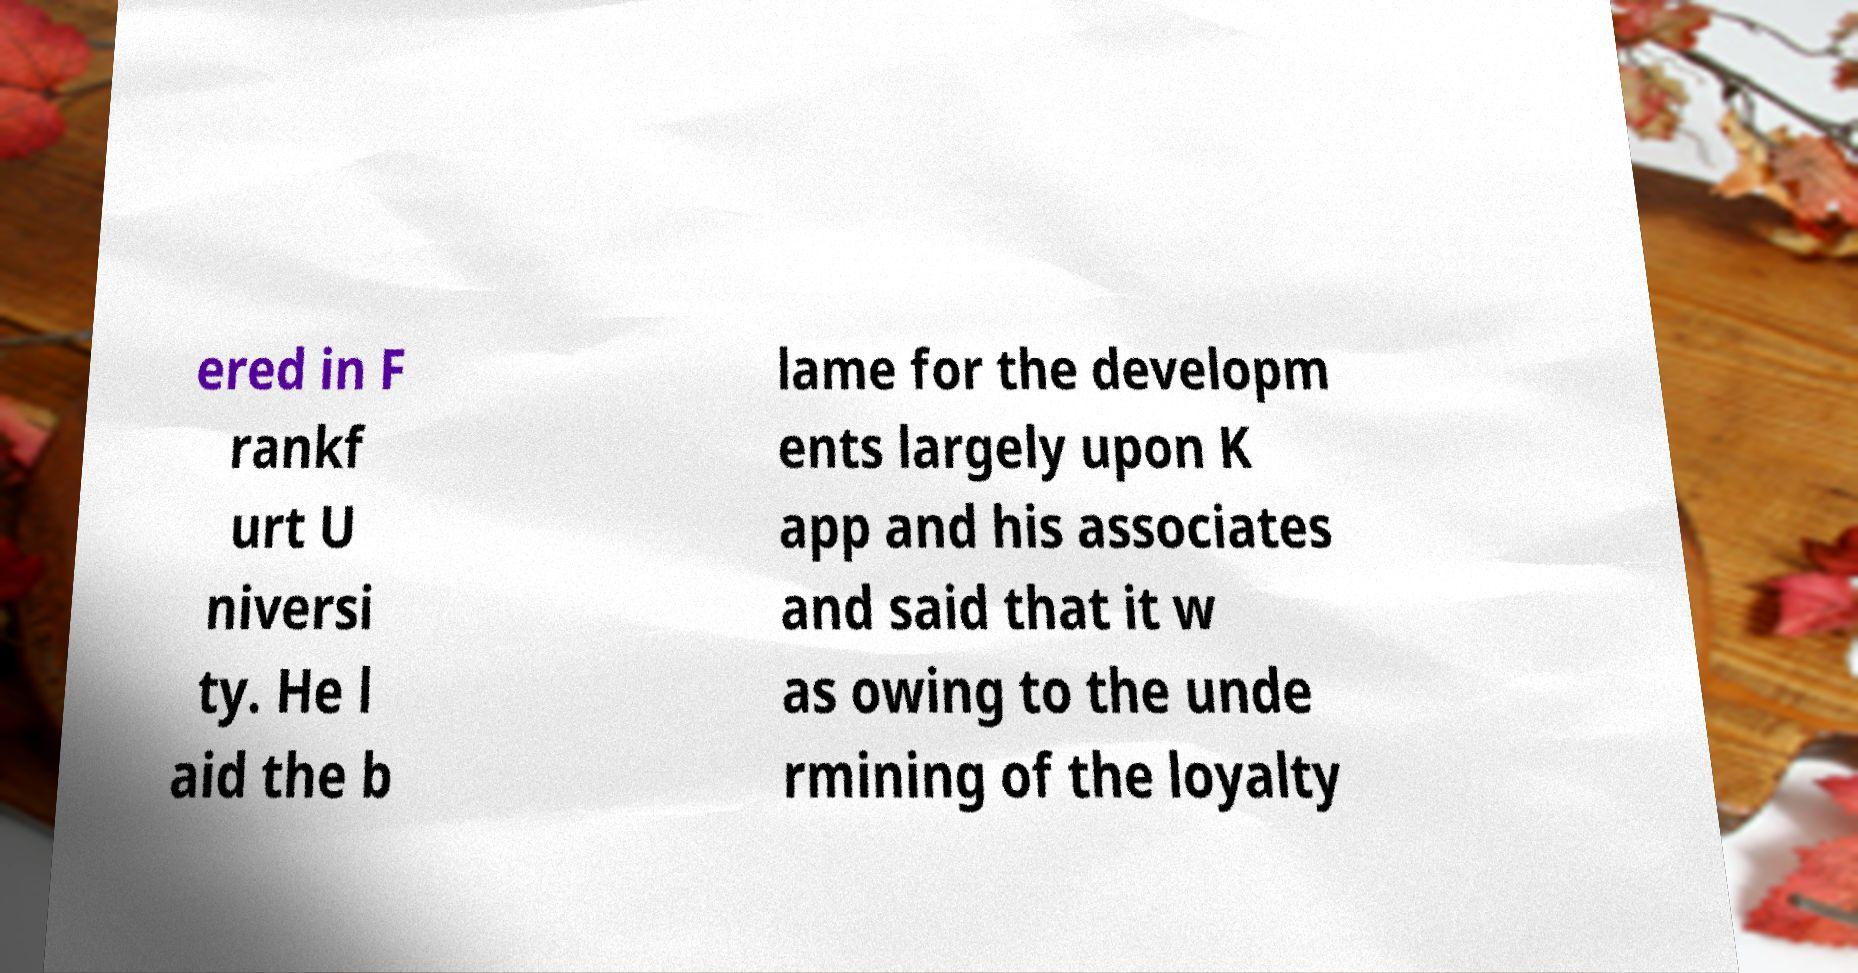Could you assist in decoding the text presented in this image and type it out clearly? ered in F rankf urt U niversi ty. He l aid the b lame for the developm ents largely upon K app and his associates and said that it w as owing to the unde rmining of the loyalty 